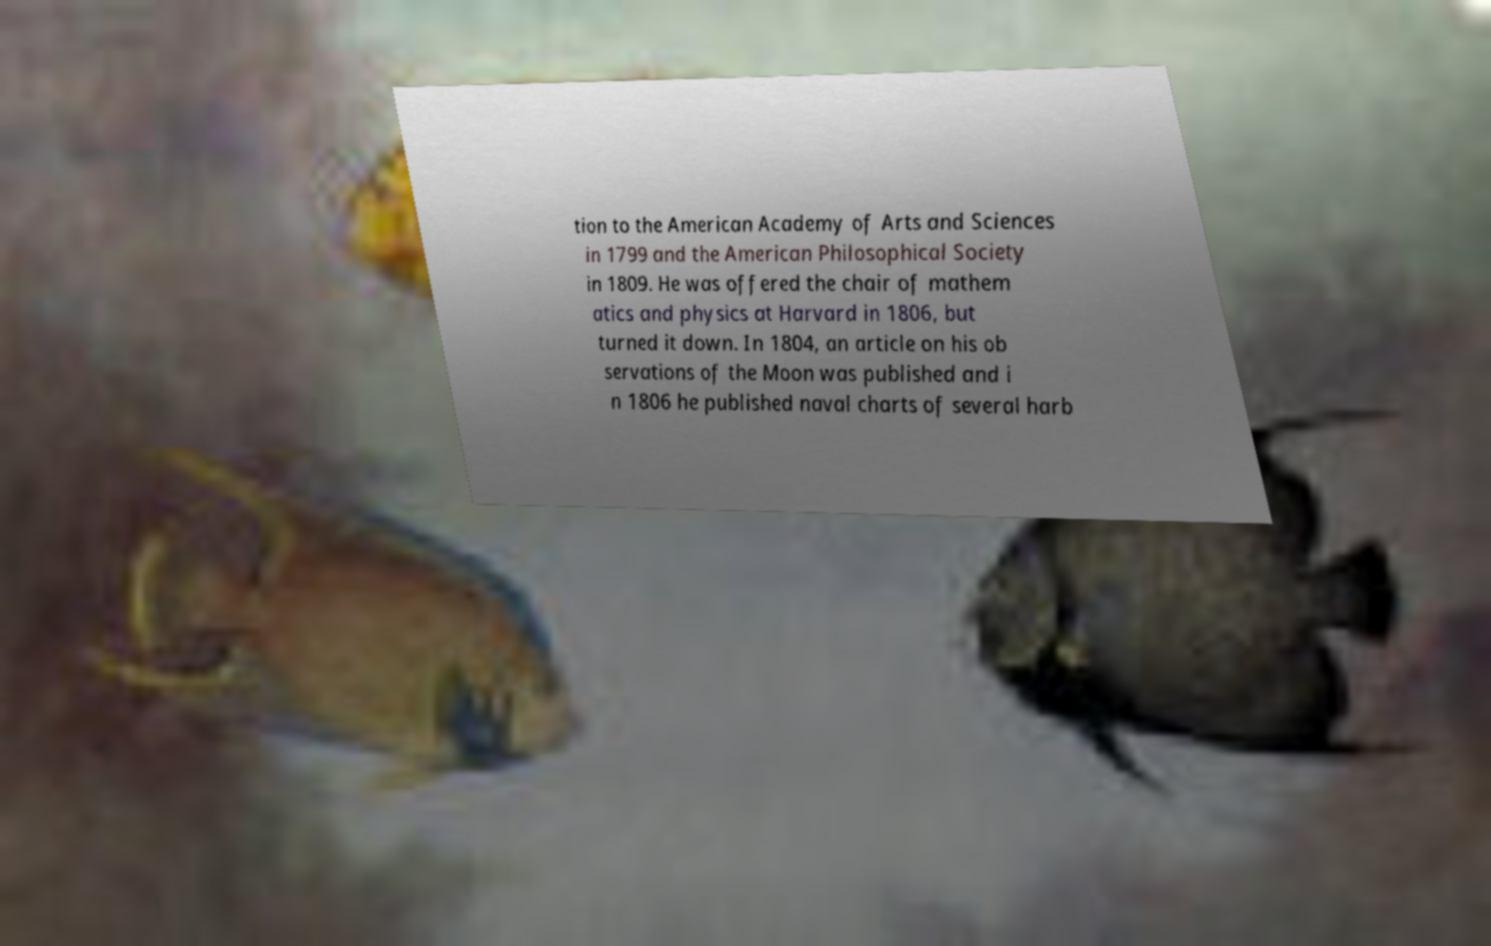Please read and relay the text visible in this image. What does it say? tion to the American Academy of Arts and Sciences in 1799 and the American Philosophical Society in 1809. He was offered the chair of mathem atics and physics at Harvard in 1806, but turned it down. In 1804, an article on his ob servations of the Moon was published and i n 1806 he published naval charts of several harb 